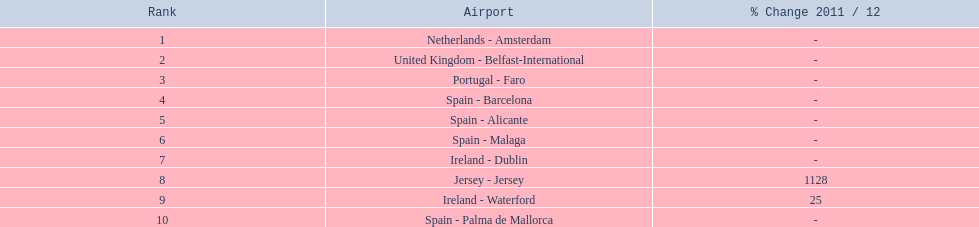What are the names of all the airports? Netherlands - Amsterdam, United Kingdom - Belfast-International, Portugal - Faro, Spain - Barcelona, Spain - Alicante, Spain - Malaga, Ireland - Dublin, Jersey - Jersey, Ireland - Waterford, Spain - Palma de Mallorca. Of these, what are all the passenger counts? 105,349, 92,502, 71,676, 66,565, 64,090, 59,175, 35,524, 35,169, 31,907, 27,718. Of these, which airport had more passengers than the united kingdom? Netherlands - Amsterdam. 